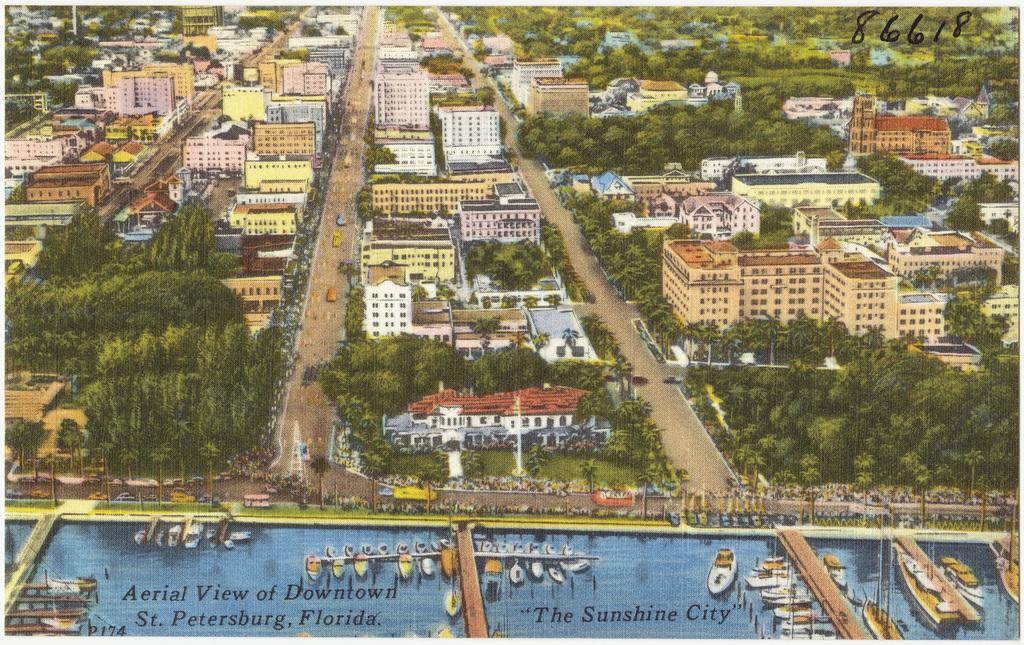What type of structures are depicted in the paintings in the image? There are paintings of buildings, trees, poles, vehicles on the road, boards, and sheds in the image. What other elements can be seen in the paintings? There are paintings of trees and poles in the image. What is the subject matter of the paintings on the boards? The paintings on the boards are not described in the image, so we cannot determine their subject matter. Can you read any text visible in the image? There is some text visible in the image, but its content is not specified. What type of cream can be seen dripping from the bulb in the image? There is no cream or bulb present in the image; it features paintings of various objects and scenes. What type of rod is used to support the sheds in the image? The image does not provide details about the construction or support of the sheds, so we cannot determine the type of rod used. 